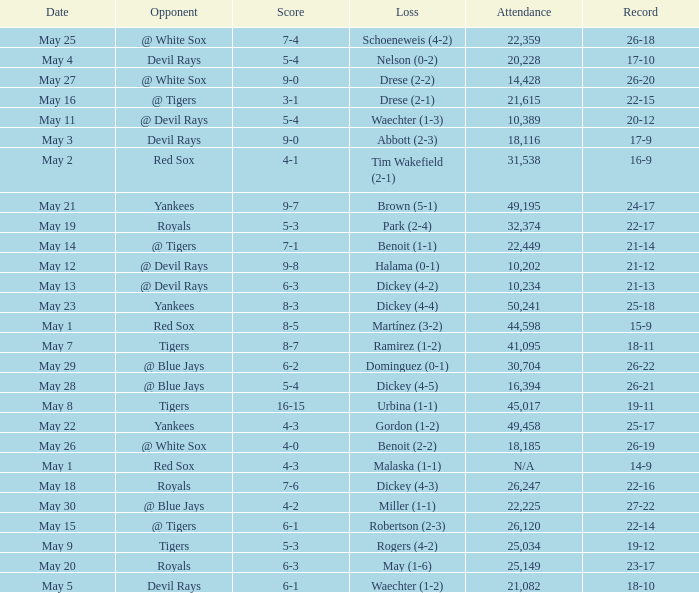What is the score of the game attended by 25,034? 5-3. 